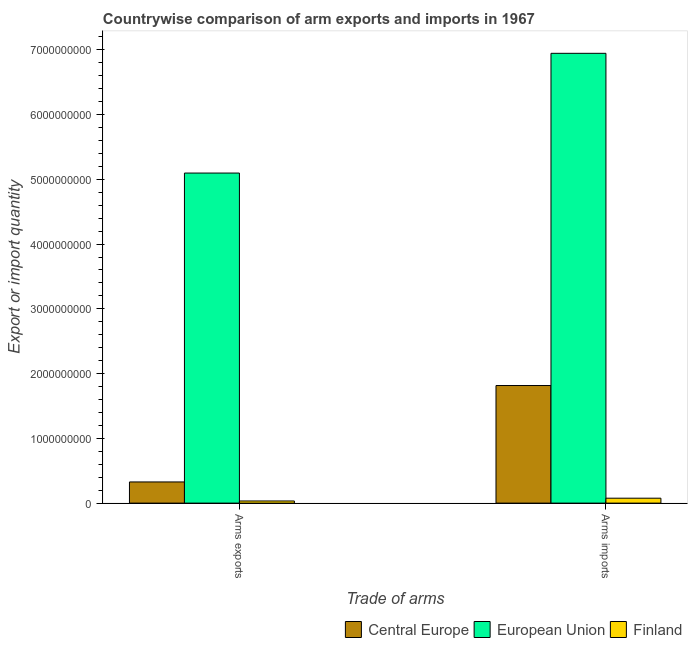How many different coloured bars are there?
Your response must be concise. 3. How many groups of bars are there?
Provide a short and direct response. 2. How many bars are there on the 1st tick from the right?
Your answer should be very brief. 3. What is the label of the 1st group of bars from the left?
Your answer should be very brief. Arms exports. What is the arms imports in Finland?
Offer a terse response. 7.60e+07. Across all countries, what is the maximum arms exports?
Offer a very short reply. 5.10e+09. Across all countries, what is the minimum arms exports?
Your answer should be compact. 3.30e+07. In which country was the arms exports maximum?
Provide a succinct answer. European Union. What is the total arms exports in the graph?
Provide a succinct answer. 5.46e+09. What is the difference between the arms exports in Finland and that in European Union?
Offer a terse response. -5.06e+09. What is the difference between the arms imports in Finland and the arms exports in European Union?
Your response must be concise. -5.02e+09. What is the average arms imports per country?
Your answer should be compact. 2.95e+09. What is the difference between the arms imports and arms exports in Central Europe?
Offer a terse response. 1.49e+09. In how many countries, is the arms exports greater than 6600000000 ?
Your answer should be very brief. 0. What is the ratio of the arms exports in Finland to that in Central Europe?
Offer a very short reply. 0.1. What does the 2nd bar from the left in Arms imports represents?
Your answer should be compact. European Union. What does the 3rd bar from the right in Arms imports represents?
Give a very brief answer. Central Europe. What is the difference between two consecutive major ticks on the Y-axis?
Provide a succinct answer. 1.00e+09. Are the values on the major ticks of Y-axis written in scientific E-notation?
Give a very brief answer. No. Does the graph contain any zero values?
Make the answer very short. No. What is the title of the graph?
Give a very brief answer. Countrywise comparison of arm exports and imports in 1967. Does "Venezuela" appear as one of the legend labels in the graph?
Your response must be concise. No. What is the label or title of the X-axis?
Your answer should be compact. Trade of arms. What is the label or title of the Y-axis?
Keep it short and to the point. Export or import quantity. What is the Export or import quantity of Central Europe in Arms exports?
Give a very brief answer. 3.27e+08. What is the Export or import quantity of European Union in Arms exports?
Your response must be concise. 5.10e+09. What is the Export or import quantity of Finland in Arms exports?
Your answer should be very brief. 3.30e+07. What is the Export or import quantity in Central Europe in Arms imports?
Your answer should be compact. 1.82e+09. What is the Export or import quantity of European Union in Arms imports?
Your answer should be compact. 6.95e+09. What is the Export or import quantity in Finland in Arms imports?
Offer a very short reply. 7.60e+07. Across all Trade of arms, what is the maximum Export or import quantity of Central Europe?
Make the answer very short. 1.82e+09. Across all Trade of arms, what is the maximum Export or import quantity in European Union?
Your answer should be very brief. 6.95e+09. Across all Trade of arms, what is the maximum Export or import quantity of Finland?
Offer a terse response. 7.60e+07. Across all Trade of arms, what is the minimum Export or import quantity of Central Europe?
Keep it short and to the point. 3.27e+08. Across all Trade of arms, what is the minimum Export or import quantity in European Union?
Offer a very short reply. 5.10e+09. Across all Trade of arms, what is the minimum Export or import quantity in Finland?
Your answer should be compact. 3.30e+07. What is the total Export or import quantity of Central Europe in the graph?
Give a very brief answer. 2.14e+09. What is the total Export or import quantity of European Union in the graph?
Ensure brevity in your answer.  1.20e+1. What is the total Export or import quantity of Finland in the graph?
Make the answer very short. 1.09e+08. What is the difference between the Export or import quantity in Central Europe in Arms exports and that in Arms imports?
Provide a succinct answer. -1.49e+09. What is the difference between the Export or import quantity of European Union in Arms exports and that in Arms imports?
Make the answer very short. -1.85e+09. What is the difference between the Export or import quantity in Finland in Arms exports and that in Arms imports?
Provide a succinct answer. -4.30e+07. What is the difference between the Export or import quantity of Central Europe in Arms exports and the Export or import quantity of European Union in Arms imports?
Give a very brief answer. -6.62e+09. What is the difference between the Export or import quantity in Central Europe in Arms exports and the Export or import quantity in Finland in Arms imports?
Provide a short and direct response. 2.51e+08. What is the difference between the Export or import quantity of European Union in Arms exports and the Export or import quantity of Finland in Arms imports?
Provide a succinct answer. 5.02e+09. What is the average Export or import quantity of Central Europe per Trade of arms?
Offer a terse response. 1.07e+09. What is the average Export or import quantity in European Union per Trade of arms?
Provide a succinct answer. 6.02e+09. What is the average Export or import quantity in Finland per Trade of arms?
Ensure brevity in your answer.  5.45e+07. What is the difference between the Export or import quantity of Central Europe and Export or import quantity of European Union in Arms exports?
Offer a terse response. -4.77e+09. What is the difference between the Export or import quantity in Central Europe and Export or import quantity in Finland in Arms exports?
Provide a short and direct response. 2.94e+08. What is the difference between the Export or import quantity in European Union and Export or import quantity in Finland in Arms exports?
Offer a terse response. 5.06e+09. What is the difference between the Export or import quantity of Central Europe and Export or import quantity of European Union in Arms imports?
Provide a succinct answer. -5.13e+09. What is the difference between the Export or import quantity of Central Europe and Export or import quantity of Finland in Arms imports?
Keep it short and to the point. 1.74e+09. What is the difference between the Export or import quantity of European Union and Export or import quantity of Finland in Arms imports?
Your answer should be very brief. 6.87e+09. What is the ratio of the Export or import quantity of Central Europe in Arms exports to that in Arms imports?
Offer a very short reply. 0.18. What is the ratio of the Export or import quantity in European Union in Arms exports to that in Arms imports?
Give a very brief answer. 0.73. What is the ratio of the Export or import quantity in Finland in Arms exports to that in Arms imports?
Your answer should be very brief. 0.43. What is the difference between the highest and the second highest Export or import quantity of Central Europe?
Give a very brief answer. 1.49e+09. What is the difference between the highest and the second highest Export or import quantity of European Union?
Your answer should be very brief. 1.85e+09. What is the difference between the highest and the second highest Export or import quantity in Finland?
Give a very brief answer. 4.30e+07. What is the difference between the highest and the lowest Export or import quantity of Central Europe?
Provide a succinct answer. 1.49e+09. What is the difference between the highest and the lowest Export or import quantity of European Union?
Ensure brevity in your answer.  1.85e+09. What is the difference between the highest and the lowest Export or import quantity in Finland?
Ensure brevity in your answer.  4.30e+07. 